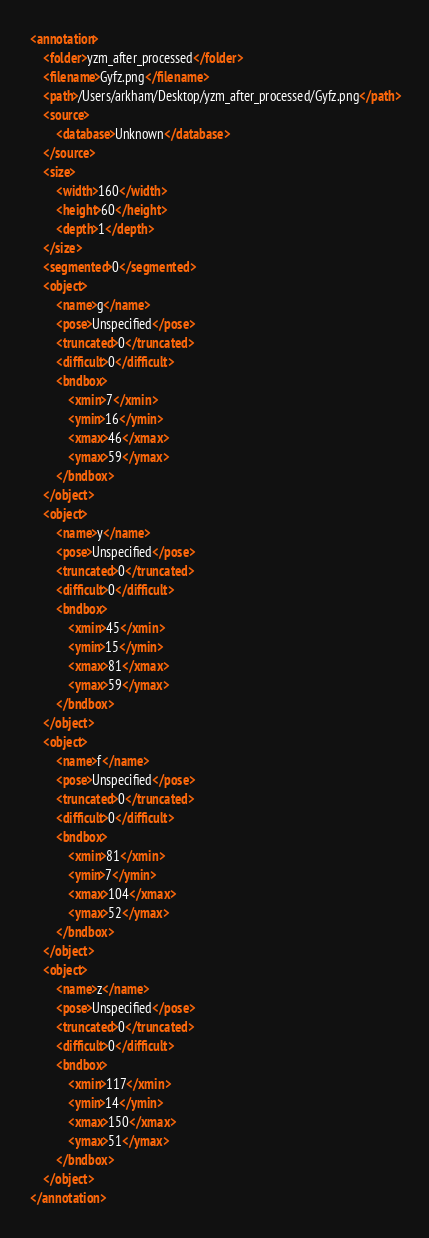<code> <loc_0><loc_0><loc_500><loc_500><_XML_><annotation>
	<folder>yzm_after_processed</folder>
	<filename>Gyfz.png</filename>
	<path>/Users/arkham/Desktop/yzm_after_processed/Gyfz.png</path>
	<source>
		<database>Unknown</database>
	</source>
	<size>
		<width>160</width>
		<height>60</height>
		<depth>1</depth>
	</size>
	<segmented>0</segmented>
	<object>
		<name>g</name>
		<pose>Unspecified</pose>
		<truncated>0</truncated>
		<difficult>0</difficult>
		<bndbox>
			<xmin>7</xmin>
			<ymin>16</ymin>
			<xmax>46</xmax>
			<ymax>59</ymax>
		</bndbox>
	</object>
	<object>
		<name>y</name>
		<pose>Unspecified</pose>
		<truncated>0</truncated>
		<difficult>0</difficult>
		<bndbox>
			<xmin>45</xmin>
			<ymin>15</ymin>
			<xmax>81</xmax>
			<ymax>59</ymax>
		</bndbox>
	</object>
	<object>
		<name>f</name>
		<pose>Unspecified</pose>
		<truncated>0</truncated>
		<difficult>0</difficult>
		<bndbox>
			<xmin>81</xmin>
			<ymin>7</ymin>
			<xmax>104</xmax>
			<ymax>52</ymax>
		</bndbox>
	</object>
	<object>
		<name>z</name>
		<pose>Unspecified</pose>
		<truncated>0</truncated>
		<difficult>0</difficult>
		<bndbox>
			<xmin>117</xmin>
			<ymin>14</ymin>
			<xmax>150</xmax>
			<ymax>51</ymax>
		</bndbox>
	</object>
</annotation>
</code> 